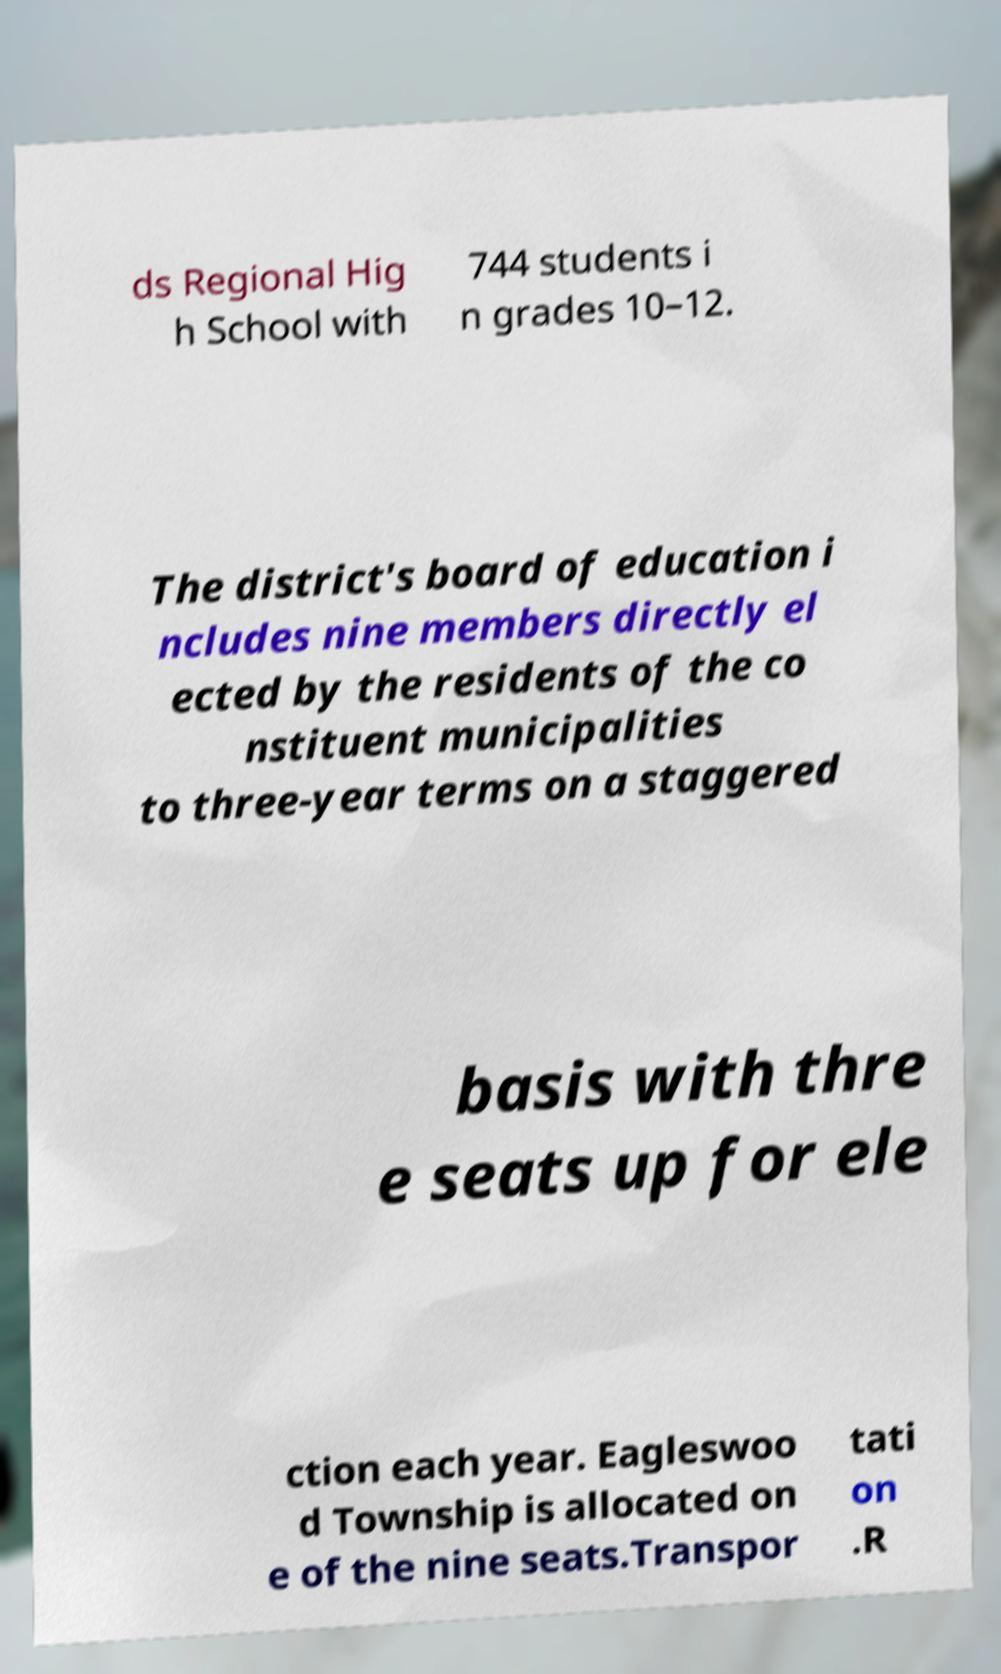There's text embedded in this image that I need extracted. Can you transcribe it verbatim? ds Regional Hig h School with 744 students i n grades 10–12. The district's board of education i ncludes nine members directly el ected by the residents of the co nstituent municipalities to three-year terms on a staggered basis with thre e seats up for ele ction each year. Eagleswoo d Township is allocated on e of the nine seats.Transpor tati on .R 